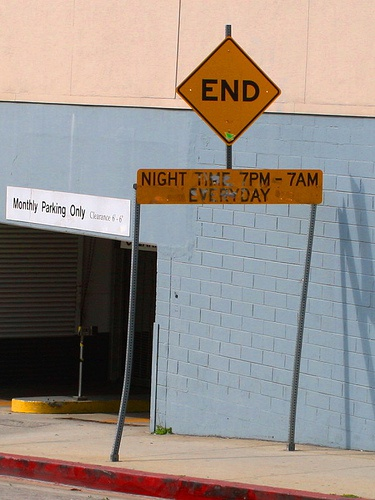Describe the objects in this image and their specific colors. I can see various objects in this image with different colors. 